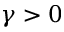<formula> <loc_0><loc_0><loc_500><loc_500>\gamma > 0</formula> 